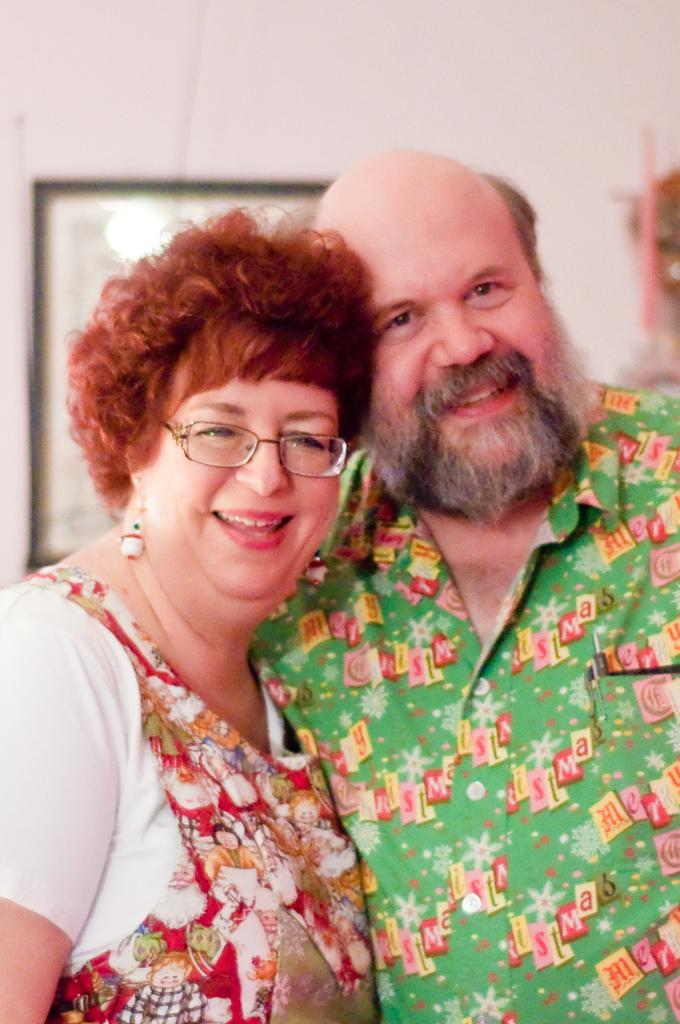Who is present in the image? There is a man and a woman in the image. What are the facial expressions of the people in the image? Both the man and the woman are smiling in the image. What accessory is the woman wearing? The woman is wearing spectacles in the image. What can be seen on the wall in the image? There is a photo frame on the wall in the image. What type of juice is being squeezed by the mountain in the image? There is no mountain or juice present in the image. 